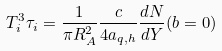<formula> <loc_0><loc_0><loc_500><loc_500>T ^ { 3 } _ { i } \tau _ { i } = \frac { 1 } { \pi R ^ { 2 } _ { A } } \frac { c } { 4 a _ { q , h } } \frac { d N } { d Y } ( b = 0 )</formula> 